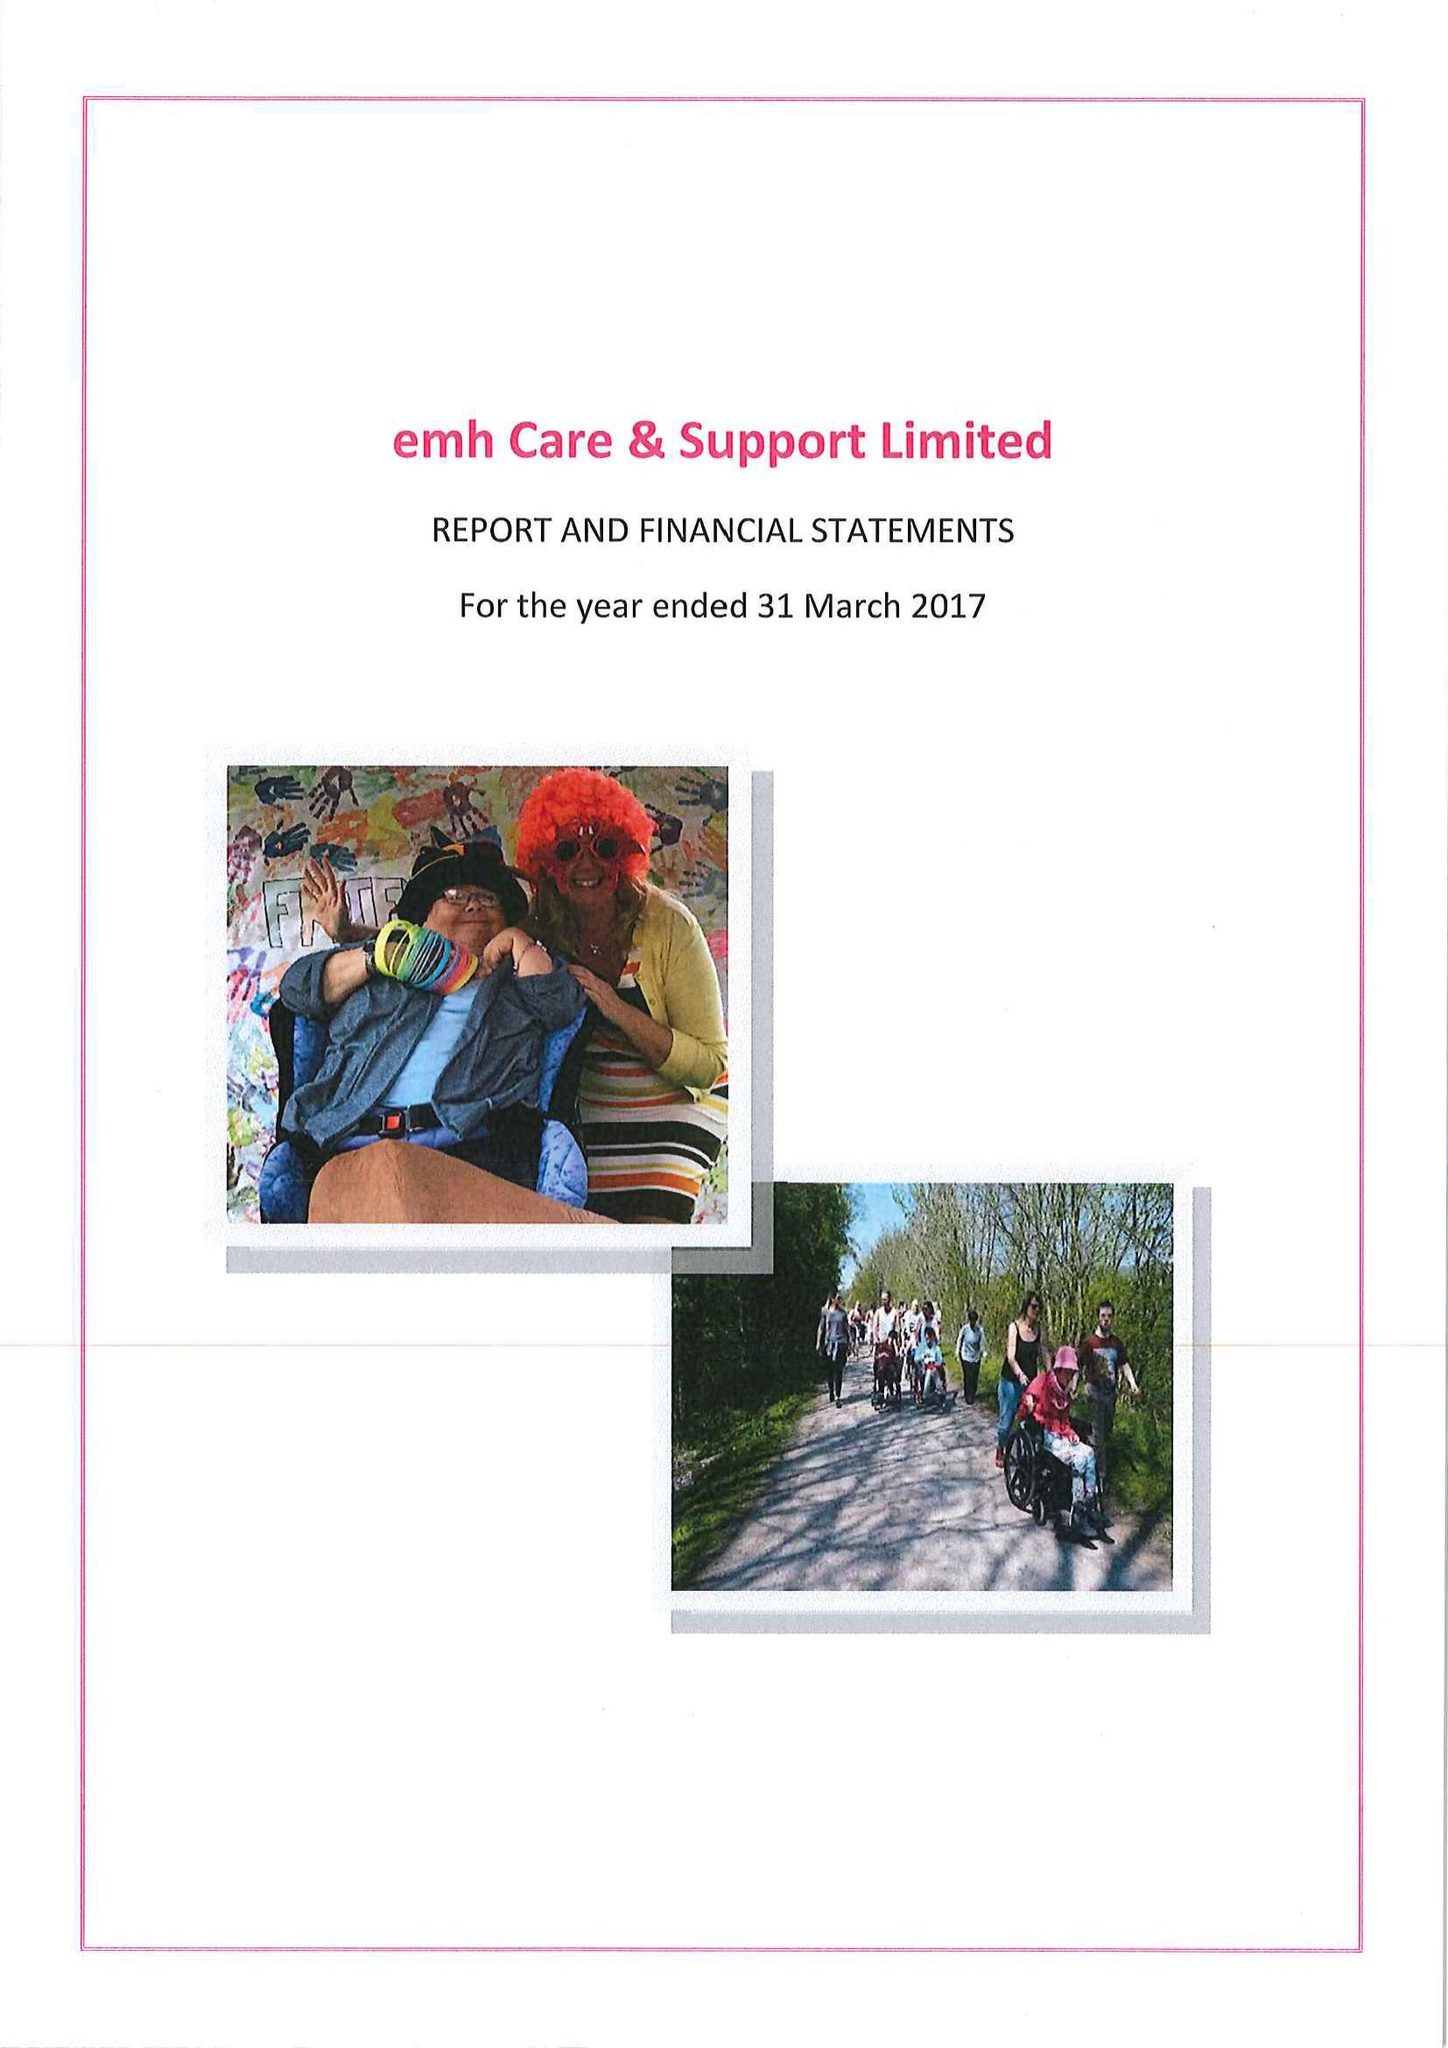What is the value for the report_date?
Answer the question using a single word or phrase. 2017-03-31 